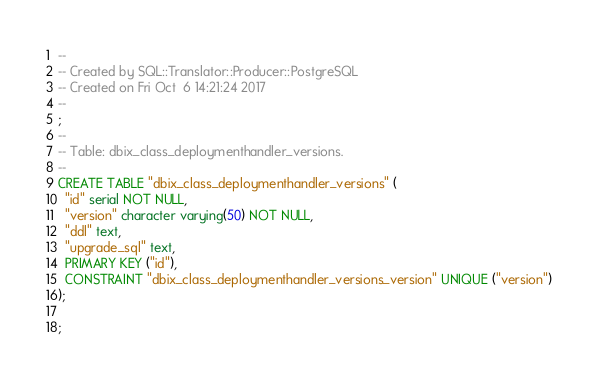<code> <loc_0><loc_0><loc_500><loc_500><_SQL_>-- 
-- Created by SQL::Translator::Producer::PostgreSQL
-- Created on Fri Oct  6 14:21:24 2017
-- 
;
--
-- Table: dbix_class_deploymenthandler_versions.
--
CREATE TABLE "dbix_class_deploymenthandler_versions" (
  "id" serial NOT NULL,
  "version" character varying(50) NOT NULL,
  "ddl" text,
  "upgrade_sql" text,
  PRIMARY KEY ("id"),
  CONSTRAINT "dbix_class_deploymenthandler_versions_version" UNIQUE ("version")
);

;
</code> 